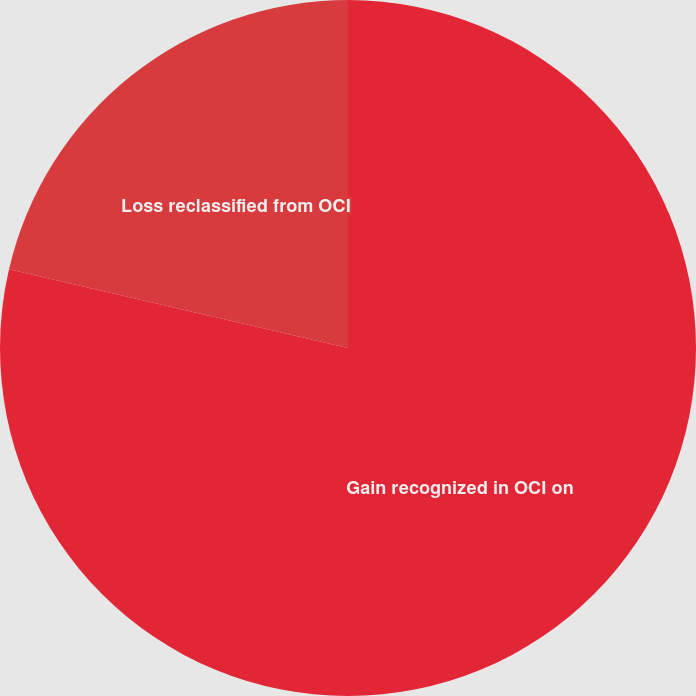<chart> <loc_0><loc_0><loc_500><loc_500><pie_chart><fcel>Gain recognized in OCI on<fcel>Loss reclassified from OCI<nl><fcel>78.63%<fcel>21.37%<nl></chart> 